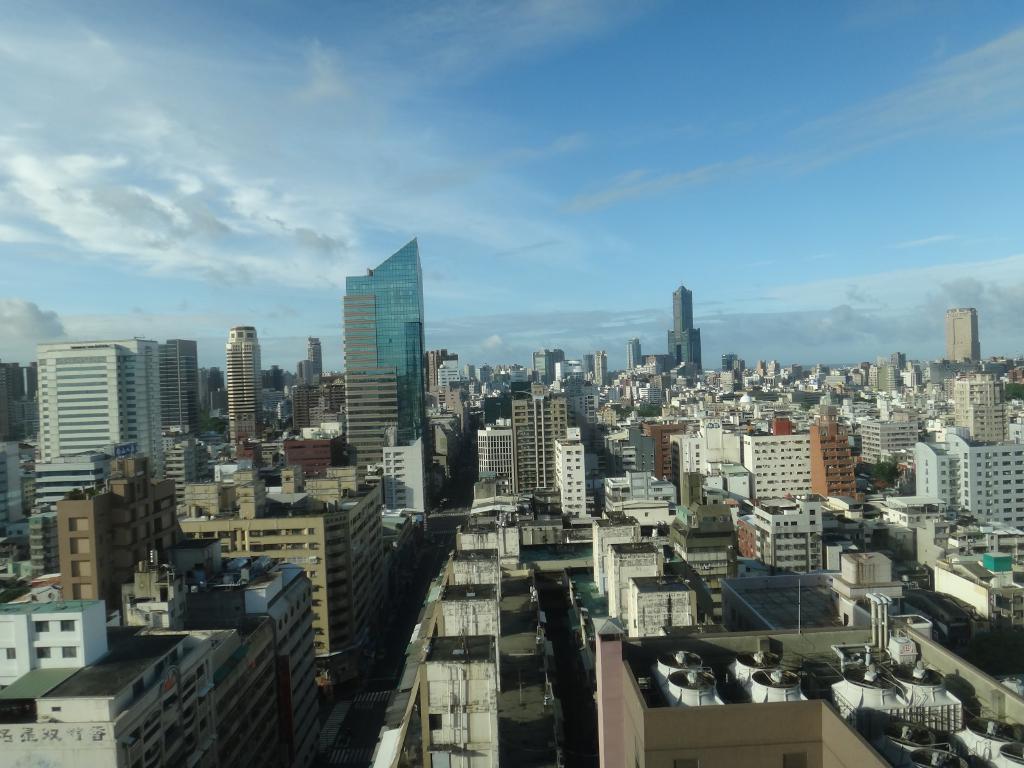Describe this image in one or two sentences. In this image we can see a group of buildings with windows. On the backside we can see the sky which looks cloudy. 